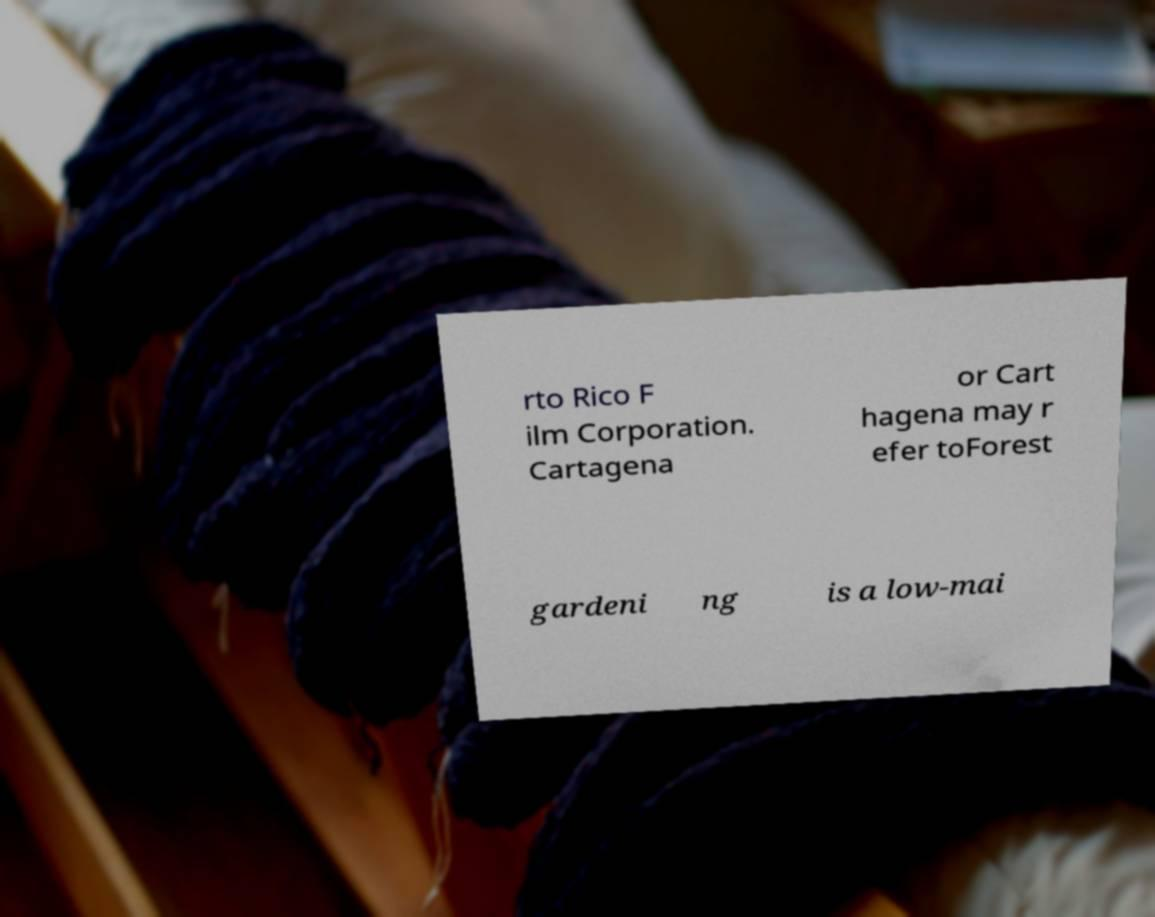For documentation purposes, I need the text within this image transcribed. Could you provide that? rto Rico F ilm Corporation. Cartagena or Cart hagena may r efer toForest gardeni ng is a low-mai 